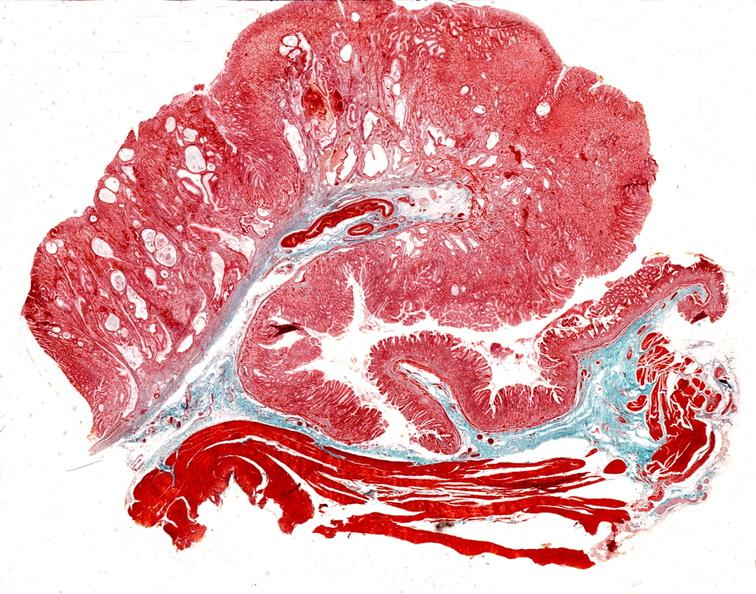what is present?
Answer the question using a single word or phrase. Gastrointestinal 